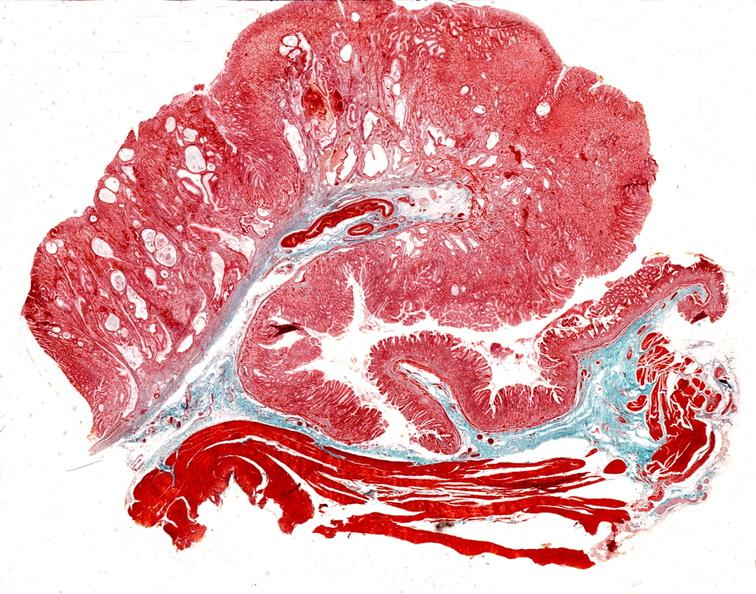what is present?
Answer the question using a single word or phrase. Gastrointestinal 